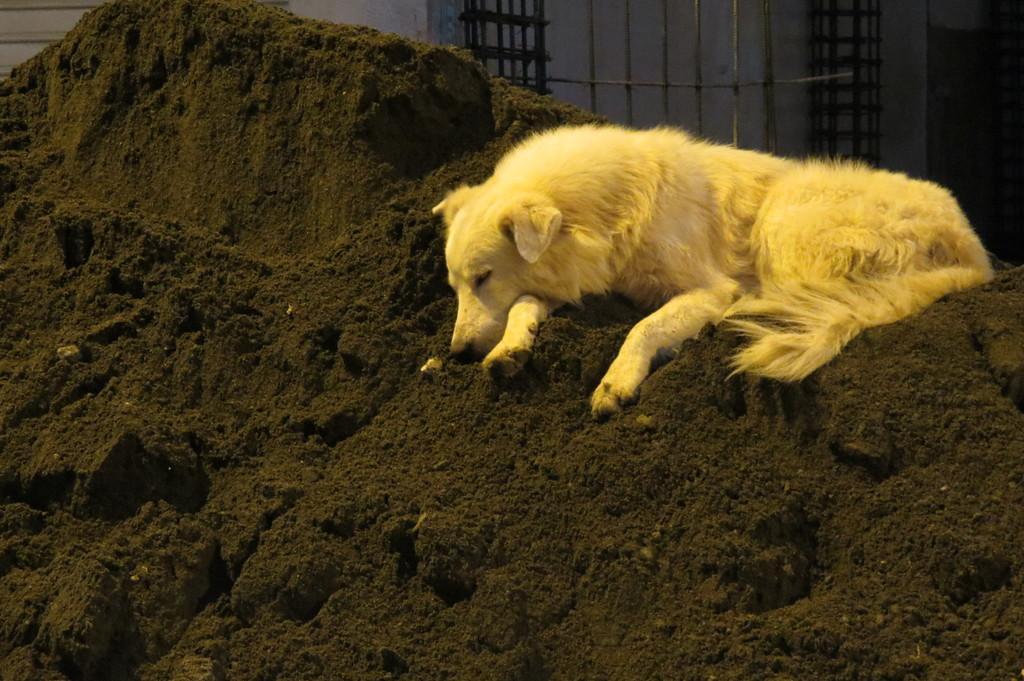Can you describe this image briefly? As we can see in the image there is mud, yellow color dog and in the background there is wall. The image is little dark. 